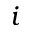<formula> <loc_0><loc_0><loc_500><loc_500>i</formula> 